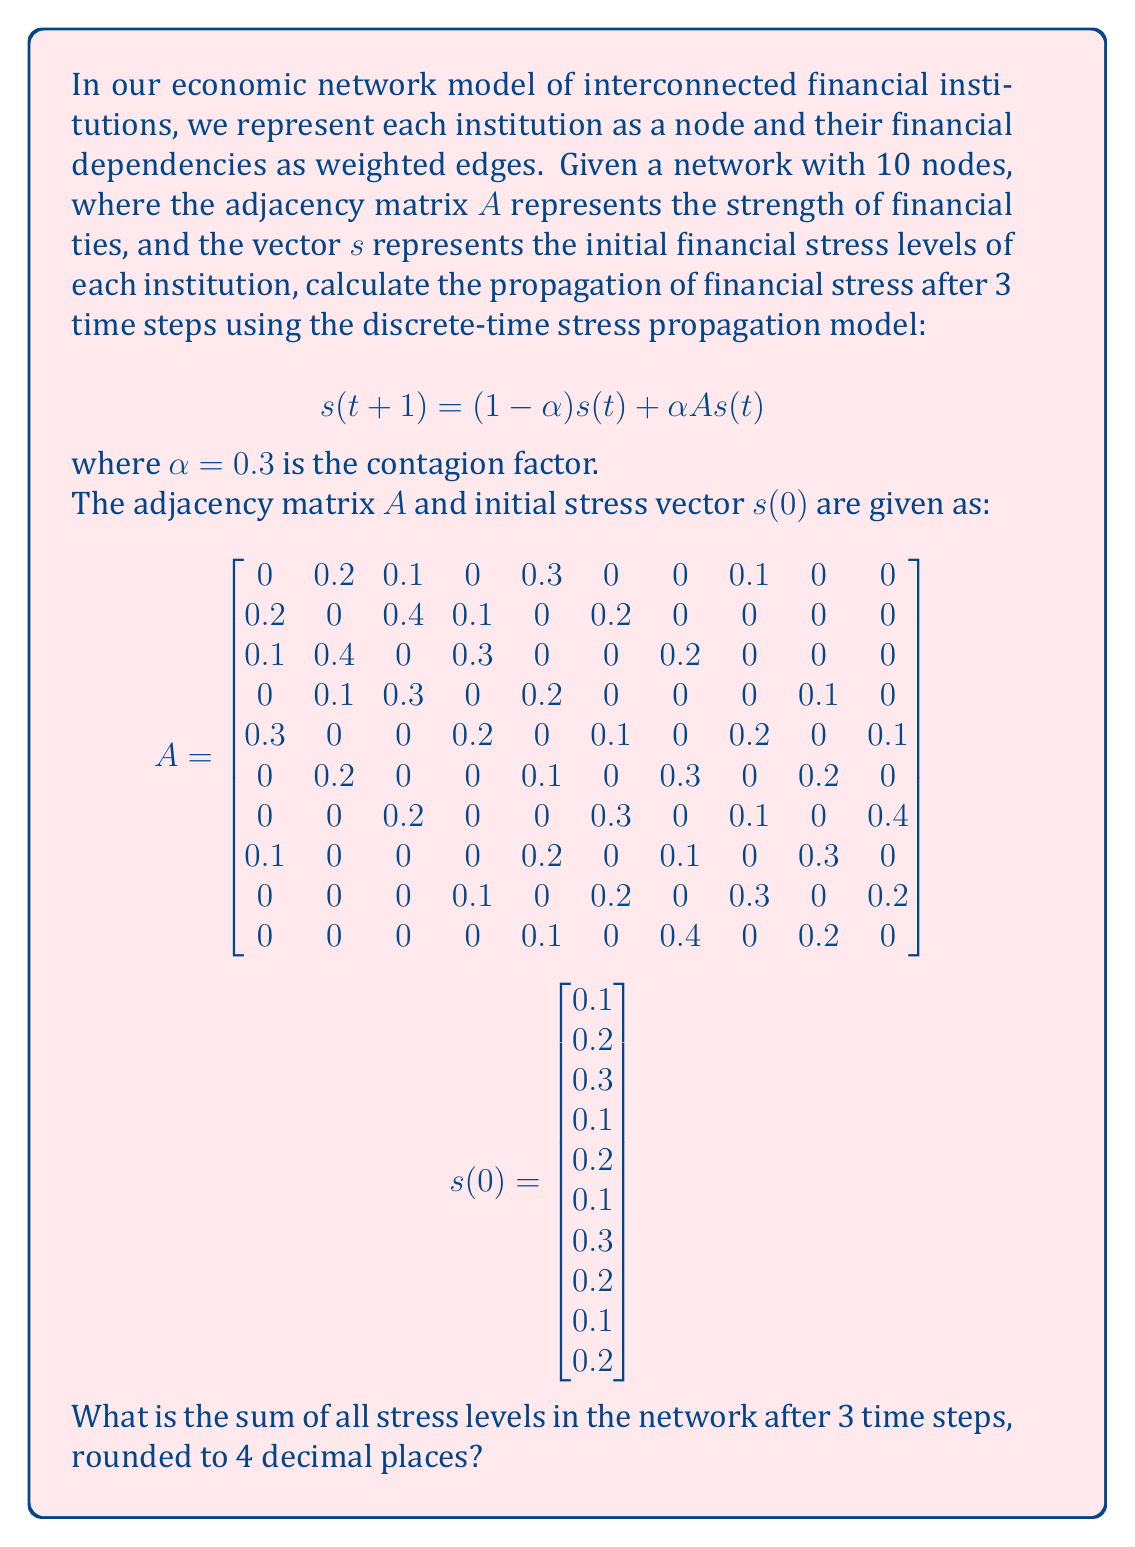Could you help me with this problem? To solve this problem, we need to iteratively apply the stress propagation model for 3 time steps. Let's break it down step by step:

1) First, let's define our equation:
   $$s(t+1) = (1-\alpha)s(t) + \alpha A s(t)$$
   where $\alpha = 0.3$

2) We can rewrite this as:
   $$s(t+1) = (0.7I + 0.3A)s(t)$$
   where $I$ is the 10x10 identity matrix

3) Let's call the matrix $(0.7I + 0.3A)$ as $M$. We need to calculate $M$:
   $$M = 0.7I + 0.3A$$

4) Now, we can calculate $s(1)$, $s(2)$, and $s(3)$ as follows:
   $$s(1) = M s(0)$$
   $$s(2) = M s(1) = M^2 s(0)$$
   $$s(3) = M s(2) = M^3 s(0)$$

5) Using a computational tool (as this involves matrix multiplication), we can calculate $M^3$ and then multiply it by $s(0)$ to get $s(3)$.

6) After performing these calculations, we get:
   $$s(3) \approx \begin{bmatrix}
   0.1912 \\ 0.2171 \\ 0.2412 \\ 0.1752 \\ 0.1991 \\ 0.1814 \\ 0.2440 \\ 0.1916 \\ 0.1670 \\ 0.1922
   \end{bmatrix}$$

7) The sum of all elements in $s(3)$ is approximately 2.0000.

8) Rounding to 4 decimal places, we get 2.0000.
Answer: 2.0000 